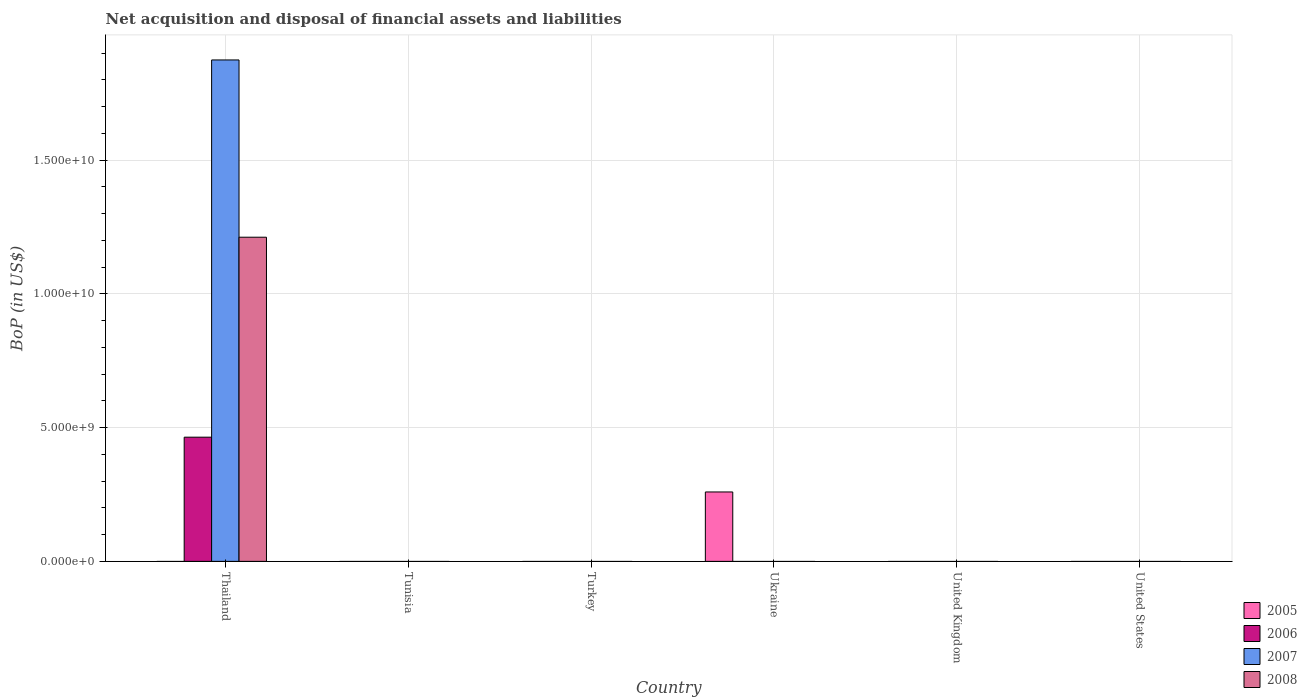How many different coloured bars are there?
Offer a terse response. 4. Are the number of bars per tick equal to the number of legend labels?
Provide a succinct answer. No. How many bars are there on the 2nd tick from the left?
Offer a very short reply. 0. How many bars are there on the 4th tick from the right?
Your response must be concise. 0. What is the Balance of Payments in 2008 in Thailand?
Your answer should be compact. 1.21e+1. Across all countries, what is the maximum Balance of Payments in 2005?
Provide a succinct answer. 2.60e+09. In which country was the Balance of Payments in 2007 maximum?
Offer a terse response. Thailand. What is the total Balance of Payments in 2008 in the graph?
Your answer should be compact. 1.21e+1. What is the difference between the Balance of Payments in 2008 in Tunisia and the Balance of Payments in 2005 in Ukraine?
Provide a short and direct response. -2.60e+09. What is the average Balance of Payments in 2008 per country?
Keep it short and to the point. 2.02e+09. What is the difference between the Balance of Payments of/in 2008 and Balance of Payments of/in 2006 in Thailand?
Provide a short and direct response. 7.48e+09. What is the difference between the highest and the lowest Balance of Payments in 2008?
Ensure brevity in your answer.  1.21e+1. In how many countries, is the Balance of Payments in 2007 greater than the average Balance of Payments in 2007 taken over all countries?
Offer a very short reply. 1. Is it the case that in every country, the sum of the Balance of Payments in 2006 and Balance of Payments in 2007 is greater than the Balance of Payments in 2008?
Your response must be concise. No. How many bars are there?
Make the answer very short. 4. What is the difference between two consecutive major ticks on the Y-axis?
Ensure brevity in your answer.  5.00e+09. Are the values on the major ticks of Y-axis written in scientific E-notation?
Your response must be concise. Yes. How are the legend labels stacked?
Provide a short and direct response. Vertical. What is the title of the graph?
Offer a terse response. Net acquisition and disposal of financial assets and liabilities. Does "2010" appear as one of the legend labels in the graph?
Give a very brief answer. No. What is the label or title of the X-axis?
Your answer should be very brief. Country. What is the label or title of the Y-axis?
Offer a very short reply. BoP (in US$). What is the BoP (in US$) in 2006 in Thailand?
Make the answer very short. 4.64e+09. What is the BoP (in US$) in 2007 in Thailand?
Ensure brevity in your answer.  1.87e+1. What is the BoP (in US$) in 2008 in Thailand?
Give a very brief answer. 1.21e+1. What is the BoP (in US$) in 2006 in Tunisia?
Your response must be concise. 0. What is the BoP (in US$) in 2008 in Tunisia?
Your answer should be compact. 0. What is the BoP (in US$) of 2006 in Turkey?
Your response must be concise. 0. What is the BoP (in US$) of 2005 in Ukraine?
Keep it short and to the point. 2.60e+09. What is the BoP (in US$) in 2007 in Ukraine?
Your answer should be compact. 0. What is the BoP (in US$) of 2008 in Ukraine?
Make the answer very short. 0. What is the BoP (in US$) in 2005 in United States?
Ensure brevity in your answer.  0. What is the BoP (in US$) of 2006 in United States?
Keep it short and to the point. 0. What is the BoP (in US$) in 2007 in United States?
Offer a very short reply. 0. What is the BoP (in US$) of 2008 in United States?
Ensure brevity in your answer.  0. Across all countries, what is the maximum BoP (in US$) of 2005?
Your answer should be compact. 2.60e+09. Across all countries, what is the maximum BoP (in US$) in 2006?
Ensure brevity in your answer.  4.64e+09. Across all countries, what is the maximum BoP (in US$) of 2007?
Offer a terse response. 1.87e+1. Across all countries, what is the maximum BoP (in US$) of 2008?
Your response must be concise. 1.21e+1. Across all countries, what is the minimum BoP (in US$) in 2005?
Make the answer very short. 0. Across all countries, what is the minimum BoP (in US$) of 2006?
Give a very brief answer. 0. Across all countries, what is the minimum BoP (in US$) of 2007?
Your answer should be compact. 0. What is the total BoP (in US$) in 2005 in the graph?
Your answer should be compact. 2.60e+09. What is the total BoP (in US$) in 2006 in the graph?
Keep it short and to the point. 4.64e+09. What is the total BoP (in US$) in 2007 in the graph?
Offer a very short reply. 1.87e+1. What is the total BoP (in US$) in 2008 in the graph?
Make the answer very short. 1.21e+1. What is the average BoP (in US$) of 2005 per country?
Your response must be concise. 4.32e+08. What is the average BoP (in US$) in 2006 per country?
Give a very brief answer. 7.74e+08. What is the average BoP (in US$) of 2007 per country?
Give a very brief answer. 3.12e+09. What is the average BoP (in US$) of 2008 per country?
Give a very brief answer. 2.02e+09. What is the difference between the BoP (in US$) of 2006 and BoP (in US$) of 2007 in Thailand?
Your answer should be compact. -1.41e+1. What is the difference between the BoP (in US$) in 2006 and BoP (in US$) in 2008 in Thailand?
Your answer should be very brief. -7.48e+09. What is the difference between the BoP (in US$) in 2007 and BoP (in US$) in 2008 in Thailand?
Provide a succinct answer. 6.63e+09. What is the difference between the highest and the lowest BoP (in US$) of 2005?
Your answer should be compact. 2.60e+09. What is the difference between the highest and the lowest BoP (in US$) in 2006?
Provide a succinct answer. 4.64e+09. What is the difference between the highest and the lowest BoP (in US$) of 2007?
Ensure brevity in your answer.  1.87e+1. What is the difference between the highest and the lowest BoP (in US$) in 2008?
Give a very brief answer. 1.21e+1. 